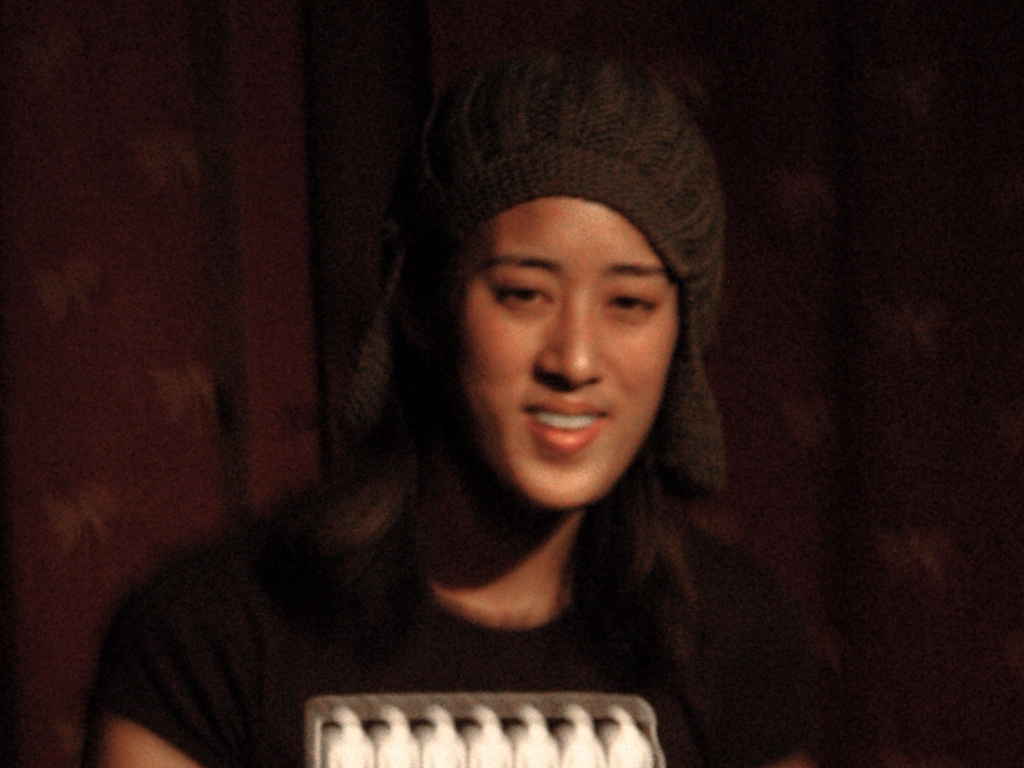What emotions might the subject in this image be feeling? Based on the subject's facial expression, with a light smile and relaxed posture, it's possible that they're feeling content or mildly amused. However, it's important to note that without additional context, it's not possible to accurately assess someone's emotions solely from an image. 